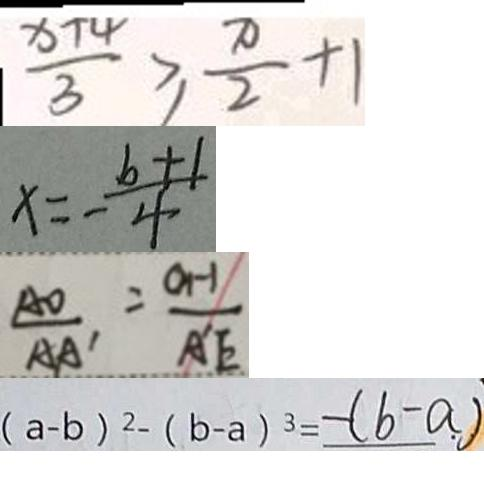Convert formula to latex. <formula><loc_0><loc_0><loc_500><loc_500>\frac { x + 4 } { 3 } \geq \frac { \pi } { 2 } + 1 
 x = - \frac { b + 1 } { 4 } 
 \frac { A O } { A A ^ { \prime } } = \frac { O H } { A ^ { \prime } E } 
 ( a - b ) ^ { 2 } - ( b - a ) ^ { 3 } = - ( b - a )</formula> 